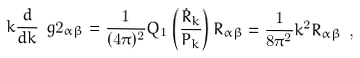Convert formula to latex. <formula><loc_0><loc_0><loc_500><loc_500>k \frac { d } { d k } \ g 2 _ { \alpha \beta } = \frac { 1 } { ( 4 \pi ) ^ { 2 } } Q _ { 1 } \left ( \frac { \dot { R } _ { k } } { P _ { k } } \right ) R _ { \alpha \beta } = \frac { 1 } { 8 \pi ^ { 2 } } k ^ { 2 } R _ { \alpha \beta } \ ,</formula> 